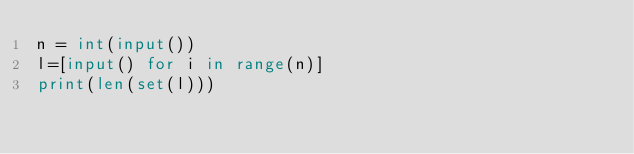<code> <loc_0><loc_0><loc_500><loc_500><_Python_>n = int(input())
l=[input() for i in range(n)]
print(len(set(l)))</code> 